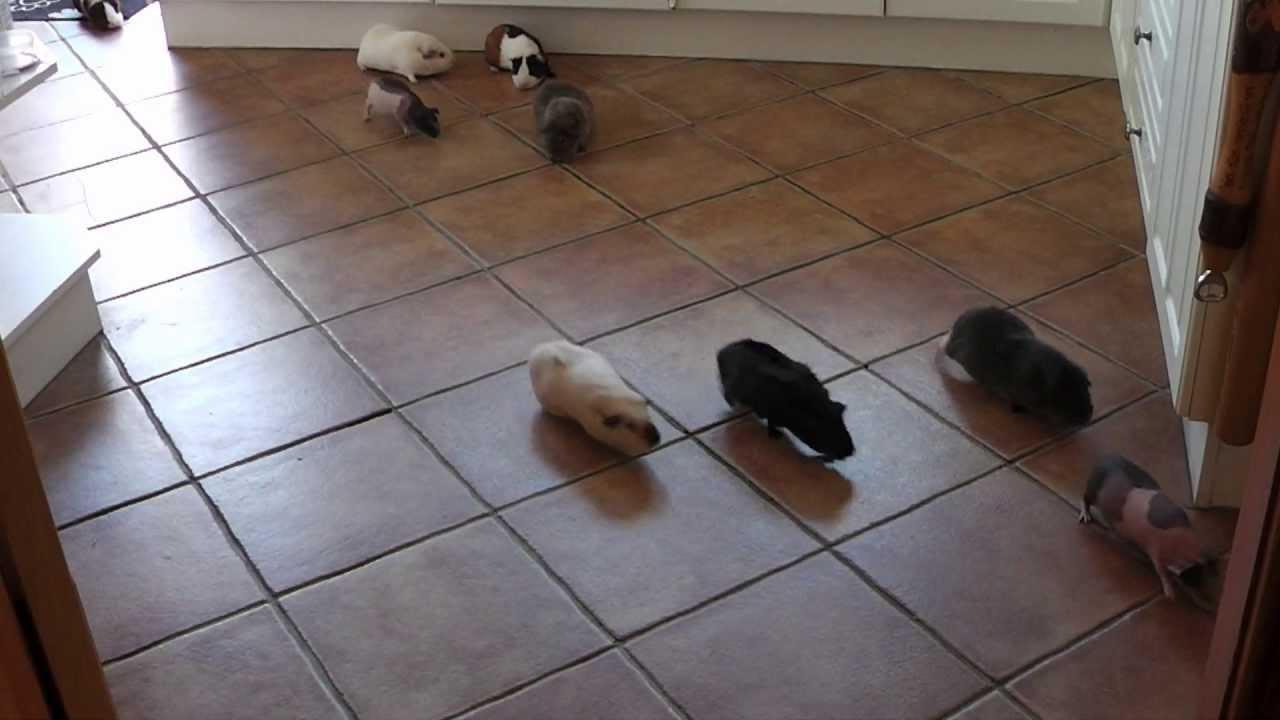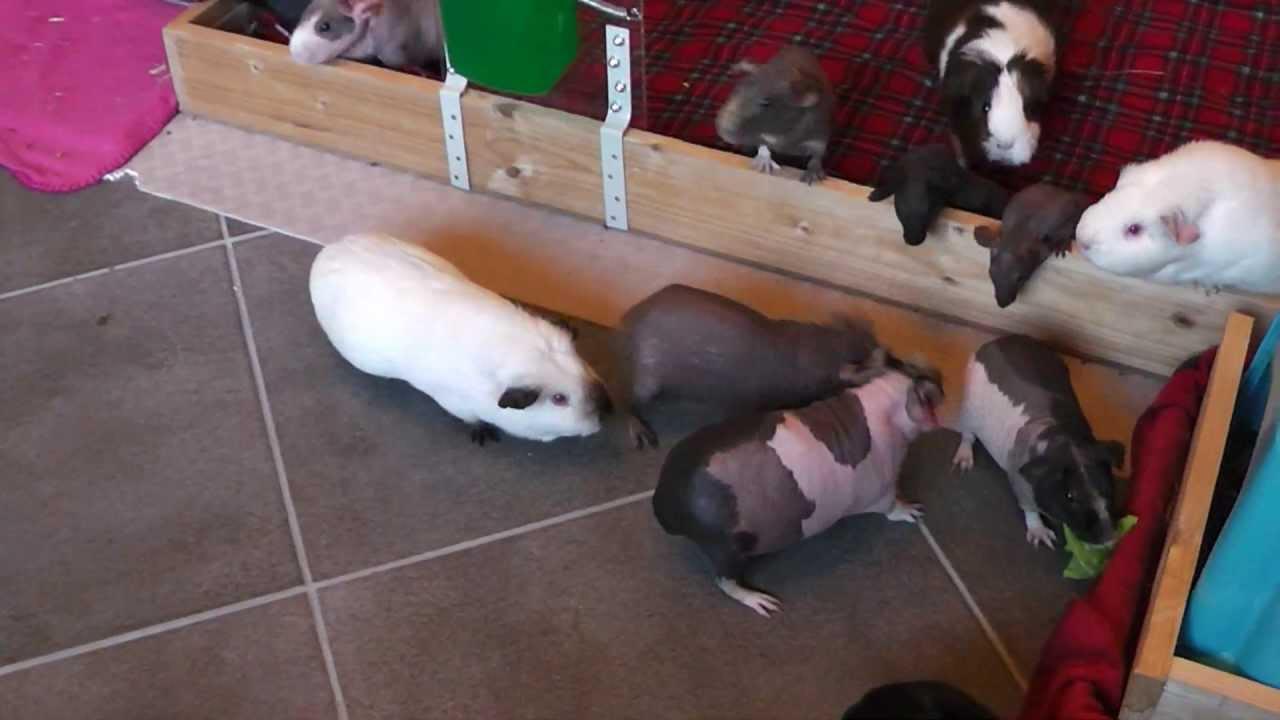The first image is the image on the left, the second image is the image on the right. For the images displayed, is the sentence "An image shows guinea pigs gathered around something """"organic"""" to eat." factually correct? Answer yes or no. No. The first image is the image on the left, the second image is the image on the right. For the images shown, is this caption "All of the guinea pigs are outside and some of them are eating greens." true? Answer yes or no. No. 